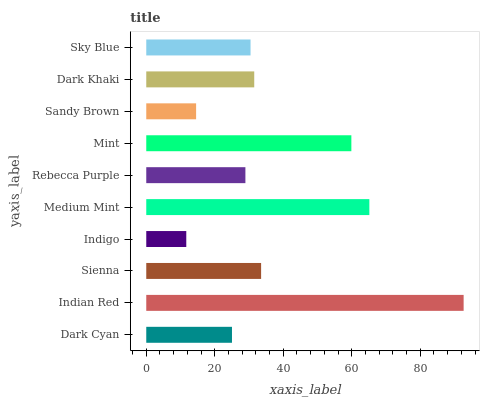Is Indigo the minimum?
Answer yes or no. Yes. Is Indian Red the maximum?
Answer yes or no. Yes. Is Sienna the minimum?
Answer yes or no. No. Is Sienna the maximum?
Answer yes or no. No. Is Indian Red greater than Sienna?
Answer yes or no. Yes. Is Sienna less than Indian Red?
Answer yes or no. Yes. Is Sienna greater than Indian Red?
Answer yes or no. No. Is Indian Red less than Sienna?
Answer yes or no. No. Is Dark Khaki the high median?
Answer yes or no. Yes. Is Sky Blue the low median?
Answer yes or no. Yes. Is Mint the high median?
Answer yes or no. No. Is Rebecca Purple the low median?
Answer yes or no. No. 